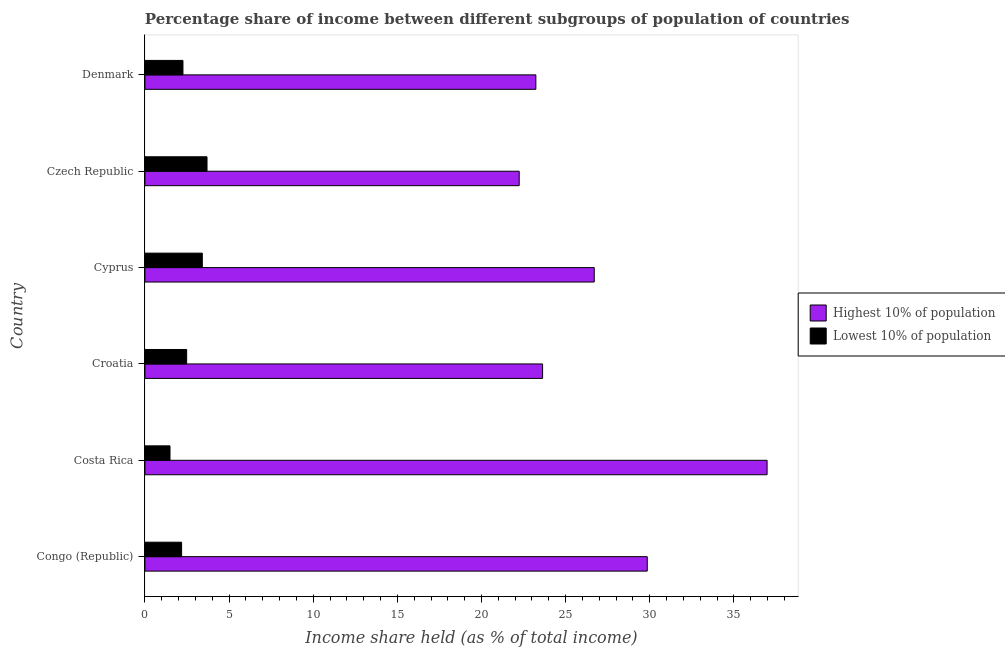How many different coloured bars are there?
Keep it short and to the point. 2. How many groups of bars are there?
Your answer should be very brief. 6. Are the number of bars on each tick of the Y-axis equal?
Provide a short and direct response. Yes. How many bars are there on the 1st tick from the bottom?
Provide a succinct answer. 2. What is the label of the 2nd group of bars from the top?
Offer a terse response. Czech Republic. In how many cases, is the number of bars for a given country not equal to the number of legend labels?
Provide a succinct answer. 0. What is the income share held by lowest 10% of the population in Denmark?
Your answer should be very brief. 2.26. Across all countries, what is the maximum income share held by lowest 10% of the population?
Offer a terse response. 3.69. Across all countries, what is the minimum income share held by lowest 10% of the population?
Keep it short and to the point. 1.49. In which country was the income share held by lowest 10% of the population maximum?
Give a very brief answer. Czech Republic. In which country was the income share held by lowest 10% of the population minimum?
Your response must be concise. Costa Rica. What is the total income share held by highest 10% of the population in the graph?
Provide a short and direct response. 162.62. What is the difference between the income share held by highest 10% of the population in Croatia and that in Denmark?
Make the answer very short. 0.4. What is the difference between the income share held by lowest 10% of the population in Costa Rica and the income share held by highest 10% of the population in Denmark?
Ensure brevity in your answer.  -21.74. What is the average income share held by highest 10% of the population per country?
Keep it short and to the point. 27.1. What is the difference between the income share held by highest 10% of the population and income share held by lowest 10% of the population in Czech Republic?
Offer a terse response. 18.55. What is the ratio of the income share held by highest 10% of the population in Czech Republic to that in Denmark?
Provide a succinct answer. 0.96. Is the income share held by highest 10% of the population in Congo (Republic) less than that in Croatia?
Make the answer very short. No. Is the difference between the income share held by highest 10% of the population in Congo (Republic) and Czech Republic greater than the difference between the income share held by lowest 10% of the population in Congo (Republic) and Czech Republic?
Make the answer very short. Yes. What is the difference between the highest and the second highest income share held by lowest 10% of the population?
Keep it short and to the point. 0.28. What is the difference between the highest and the lowest income share held by lowest 10% of the population?
Keep it short and to the point. 2.2. In how many countries, is the income share held by lowest 10% of the population greater than the average income share held by lowest 10% of the population taken over all countries?
Keep it short and to the point. 2. Is the sum of the income share held by lowest 10% of the population in Costa Rica and Croatia greater than the maximum income share held by highest 10% of the population across all countries?
Offer a terse response. No. What does the 2nd bar from the top in Czech Republic represents?
Keep it short and to the point. Highest 10% of population. What does the 2nd bar from the bottom in Czech Republic represents?
Your response must be concise. Lowest 10% of population. How many countries are there in the graph?
Make the answer very short. 6. What is the difference between two consecutive major ticks on the X-axis?
Your response must be concise. 5. Does the graph contain any zero values?
Ensure brevity in your answer.  No. Does the graph contain grids?
Give a very brief answer. No. Where does the legend appear in the graph?
Keep it short and to the point. Center right. What is the title of the graph?
Give a very brief answer. Percentage share of income between different subgroups of population of countries. What is the label or title of the X-axis?
Offer a terse response. Income share held (as % of total income). What is the Income share held (as % of total income) of Highest 10% of population in Congo (Republic)?
Keep it short and to the point. 29.85. What is the Income share held (as % of total income) of Lowest 10% of population in Congo (Republic)?
Provide a short and direct response. 2.18. What is the Income share held (as % of total income) in Highest 10% of population in Costa Rica?
Ensure brevity in your answer.  36.97. What is the Income share held (as % of total income) of Lowest 10% of population in Costa Rica?
Give a very brief answer. 1.49. What is the Income share held (as % of total income) in Highest 10% of population in Croatia?
Provide a succinct answer. 23.63. What is the Income share held (as % of total income) of Lowest 10% of population in Croatia?
Offer a terse response. 2.48. What is the Income share held (as % of total income) in Highest 10% of population in Cyprus?
Your answer should be compact. 26.7. What is the Income share held (as % of total income) in Lowest 10% of population in Cyprus?
Your response must be concise. 3.41. What is the Income share held (as % of total income) in Highest 10% of population in Czech Republic?
Make the answer very short. 22.24. What is the Income share held (as % of total income) of Lowest 10% of population in Czech Republic?
Your answer should be compact. 3.69. What is the Income share held (as % of total income) in Highest 10% of population in Denmark?
Offer a very short reply. 23.23. What is the Income share held (as % of total income) of Lowest 10% of population in Denmark?
Give a very brief answer. 2.26. Across all countries, what is the maximum Income share held (as % of total income) in Highest 10% of population?
Provide a short and direct response. 36.97. Across all countries, what is the maximum Income share held (as % of total income) in Lowest 10% of population?
Your answer should be very brief. 3.69. Across all countries, what is the minimum Income share held (as % of total income) of Highest 10% of population?
Offer a terse response. 22.24. Across all countries, what is the minimum Income share held (as % of total income) in Lowest 10% of population?
Provide a short and direct response. 1.49. What is the total Income share held (as % of total income) in Highest 10% of population in the graph?
Offer a terse response. 162.62. What is the total Income share held (as % of total income) in Lowest 10% of population in the graph?
Your answer should be very brief. 15.51. What is the difference between the Income share held (as % of total income) in Highest 10% of population in Congo (Republic) and that in Costa Rica?
Your answer should be very brief. -7.12. What is the difference between the Income share held (as % of total income) of Lowest 10% of population in Congo (Republic) and that in Costa Rica?
Make the answer very short. 0.69. What is the difference between the Income share held (as % of total income) of Highest 10% of population in Congo (Republic) and that in Croatia?
Provide a succinct answer. 6.22. What is the difference between the Income share held (as % of total income) of Highest 10% of population in Congo (Republic) and that in Cyprus?
Give a very brief answer. 3.15. What is the difference between the Income share held (as % of total income) in Lowest 10% of population in Congo (Republic) and that in Cyprus?
Ensure brevity in your answer.  -1.23. What is the difference between the Income share held (as % of total income) of Highest 10% of population in Congo (Republic) and that in Czech Republic?
Keep it short and to the point. 7.61. What is the difference between the Income share held (as % of total income) in Lowest 10% of population in Congo (Republic) and that in Czech Republic?
Give a very brief answer. -1.51. What is the difference between the Income share held (as % of total income) in Highest 10% of population in Congo (Republic) and that in Denmark?
Give a very brief answer. 6.62. What is the difference between the Income share held (as % of total income) in Lowest 10% of population in Congo (Republic) and that in Denmark?
Your answer should be compact. -0.08. What is the difference between the Income share held (as % of total income) of Highest 10% of population in Costa Rica and that in Croatia?
Offer a very short reply. 13.34. What is the difference between the Income share held (as % of total income) of Lowest 10% of population in Costa Rica and that in Croatia?
Keep it short and to the point. -0.99. What is the difference between the Income share held (as % of total income) of Highest 10% of population in Costa Rica and that in Cyprus?
Your answer should be very brief. 10.27. What is the difference between the Income share held (as % of total income) of Lowest 10% of population in Costa Rica and that in Cyprus?
Offer a very short reply. -1.92. What is the difference between the Income share held (as % of total income) of Highest 10% of population in Costa Rica and that in Czech Republic?
Your answer should be very brief. 14.73. What is the difference between the Income share held (as % of total income) of Lowest 10% of population in Costa Rica and that in Czech Republic?
Give a very brief answer. -2.2. What is the difference between the Income share held (as % of total income) in Highest 10% of population in Costa Rica and that in Denmark?
Make the answer very short. 13.74. What is the difference between the Income share held (as % of total income) of Lowest 10% of population in Costa Rica and that in Denmark?
Offer a terse response. -0.77. What is the difference between the Income share held (as % of total income) of Highest 10% of population in Croatia and that in Cyprus?
Ensure brevity in your answer.  -3.07. What is the difference between the Income share held (as % of total income) of Lowest 10% of population in Croatia and that in Cyprus?
Give a very brief answer. -0.93. What is the difference between the Income share held (as % of total income) of Highest 10% of population in Croatia and that in Czech Republic?
Make the answer very short. 1.39. What is the difference between the Income share held (as % of total income) of Lowest 10% of population in Croatia and that in Czech Republic?
Give a very brief answer. -1.21. What is the difference between the Income share held (as % of total income) in Highest 10% of population in Croatia and that in Denmark?
Keep it short and to the point. 0.4. What is the difference between the Income share held (as % of total income) of Lowest 10% of population in Croatia and that in Denmark?
Offer a very short reply. 0.22. What is the difference between the Income share held (as % of total income) of Highest 10% of population in Cyprus and that in Czech Republic?
Keep it short and to the point. 4.46. What is the difference between the Income share held (as % of total income) of Lowest 10% of population in Cyprus and that in Czech Republic?
Your response must be concise. -0.28. What is the difference between the Income share held (as % of total income) of Highest 10% of population in Cyprus and that in Denmark?
Keep it short and to the point. 3.47. What is the difference between the Income share held (as % of total income) of Lowest 10% of population in Cyprus and that in Denmark?
Ensure brevity in your answer.  1.15. What is the difference between the Income share held (as % of total income) of Highest 10% of population in Czech Republic and that in Denmark?
Your answer should be very brief. -0.99. What is the difference between the Income share held (as % of total income) of Lowest 10% of population in Czech Republic and that in Denmark?
Keep it short and to the point. 1.43. What is the difference between the Income share held (as % of total income) in Highest 10% of population in Congo (Republic) and the Income share held (as % of total income) in Lowest 10% of population in Costa Rica?
Your response must be concise. 28.36. What is the difference between the Income share held (as % of total income) of Highest 10% of population in Congo (Republic) and the Income share held (as % of total income) of Lowest 10% of population in Croatia?
Provide a succinct answer. 27.37. What is the difference between the Income share held (as % of total income) of Highest 10% of population in Congo (Republic) and the Income share held (as % of total income) of Lowest 10% of population in Cyprus?
Make the answer very short. 26.44. What is the difference between the Income share held (as % of total income) of Highest 10% of population in Congo (Republic) and the Income share held (as % of total income) of Lowest 10% of population in Czech Republic?
Give a very brief answer. 26.16. What is the difference between the Income share held (as % of total income) in Highest 10% of population in Congo (Republic) and the Income share held (as % of total income) in Lowest 10% of population in Denmark?
Offer a terse response. 27.59. What is the difference between the Income share held (as % of total income) of Highest 10% of population in Costa Rica and the Income share held (as % of total income) of Lowest 10% of population in Croatia?
Your answer should be compact. 34.49. What is the difference between the Income share held (as % of total income) of Highest 10% of population in Costa Rica and the Income share held (as % of total income) of Lowest 10% of population in Cyprus?
Your response must be concise. 33.56. What is the difference between the Income share held (as % of total income) in Highest 10% of population in Costa Rica and the Income share held (as % of total income) in Lowest 10% of population in Czech Republic?
Your response must be concise. 33.28. What is the difference between the Income share held (as % of total income) of Highest 10% of population in Costa Rica and the Income share held (as % of total income) of Lowest 10% of population in Denmark?
Your response must be concise. 34.71. What is the difference between the Income share held (as % of total income) of Highest 10% of population in Croatia and the Income share held (as % of total income) of Lowest 10% of population in Cyprus?
Your response must be concise. 20.22. What is the difference between the Income share held (as % of total income) in Highest 10% of population in Croatia and the Income share held (as % of total income) in Lowest 10% of population in Czech Republic?
Offer a very short reply. 19.94. What is the difference between the Income share held (as % of total income) of Highest 10% of population in Croatia and the Income share held (as % of total income) of Lowest 10% of population in Denmark?
Your answer should be very brief. 21.37. What is the difference between the Income share held (as % of total income) of Highest 10% of population in Cyprus and the Income share held (as % of total income) of Lowest 10% of population in Czech Republic?
Make the answer very short. 23.01. What is the difference between the Income share held (as % of total income) of Highest 10% of population in Cyprus and the Income share held (as % of total income) of Lowest 10% of population in Denmark?
Provide a short and direct response. 24.44. What is the difference between the Income share held (as % of total income) of Highest 10% of population in Czech Republic and the Income share held (as % of total income) of Lowest 10% of population in Denmark?
Offer a terse response. 19.98. What is the average Income share held (as % of total income) in Highest 10% of population per country?
Ensure brevity in your answer.  27.1. What is the average Income share held (as % of total income) of Lowest 10% of population per country?
Provide a short and direct response. 2.58. What is the difference between the Income share held (as % of total income) of Highest 10% of population and Income share held (as % of total income) of Lowest 10% of population in Congo (Republic)?
Your answer should be very brief. 27.67. What is the difference between the Income share held (as % of total income) in Highest 10% of population and Income share held (as % of total income) in Lowest 10% of population in Costa Rica?
Make the answer very short. 35.48. What is the difference between the Income share held (as % of total income) of Highest 10% of population and Income share held (as % of total income) of Lowest 10% of population in Croatia?
Your answer should be very brief. 21.15. What is the difference between the Income share held (as % of total income) of Highest 10% of population and Income share held (as % of total income) of Lowest 10% of population in Cyprus?
Keep it short and to the point. 23.29. What is the difference between the Income share held (as % of total income) in Highest 10% of population and Income share held (as % of total income) in Lowest 10% of population in Czech Republic?
Your response must be concise. 18.55. What is the difference between the Income share held (as % of total income) of Highest 10% of population and Income share held (as % of total income) of Lowest 10% of population in Denmark?
Offer a very short reply. 20.97. What is the ratio of the Income share held (as % of total income) of Highest 10% of population in Congo (Republic) to that in Costa Rica?
Offer a terse response. 0.81. What is the ratio of the Income share held (as % of total income) of Lowest 10% of population in Congo (Republic) to that in Costa Rica?
Ensure brevity in your answer.  1.46. What is the ratio of the Income share held (as % of total income) of Highest 10% of population in Congo (Republic) to that in Croatia?
Your answer should be compact. 1.26. What is the ratio of the Income share held (as % of total income) in Lowest 10% of population in Congo (Republic) to that in Croatia?
Give a very brief answer. 0.88. What is the ratio of the Income share held (as % of total income) of Highest 10% of population in Congo (Republic) to that in Cyprus?
Provide a short and direct response. 1.12. What is the ratio of the Income share held (as % of total income) in Lowest 10% of population in Congo (Republic) to that in Cyprus?
Provide a succinct answer. 0.64. What is the ratio of the Income share held (as % of total income) of Highest 10% of population in Congo (Republic) to that in Czech Republic?
Your response must be concise. 1.34. What is the ratio of the Income share held (as % of total income) in Lowest 10% of population in Congo (Republic) to that in Czech Republic?
Your response must be concise. 0.59. What is the ratio of the Income share held (as % of total income) in Highest 10% of population in Congo (Republic) to that in Denmark?
Your answer should be very brief. 1.28. What is the ratio of the Income share held (as % of total income) in Lowest 10% of population in Congo (Republic) to that in Denmark?
Ensure brevity in your answer.  0.96. What is the ratio of the Income share held (as % of total income) of Highest 10% of population in Costa Rica to that in Croatia?
Your response must be concise. 1.56. What is the ratio of the Income share held (as % of total income) in Lowest 10% of population in Costa Rica to that in Croatia?
Provide a succinct answer. 0.6. What is the ratio of the Income share held (as % of total income) in Highest 10% of population in Costa Rica to that in Cyprus?
Make the answer very short. 1.38. What is the ratio of the Income share held (as % of total income) in Lowest 10% of population in Costa Rica to that in Cyprus?
Provide a succinct answer. 0.44. What is the ratio of the Income share held (as % of total income) in Highest 10% of population in Costa Rica to that in Czech Republic?
Make the answer very short. 1.66. What is the ratio of the Income share held (as % of total income) of Lowest 10% of population in Costa Rica to that in Czech Republic?
Your response must be concise. 0.4. What is the ratio of the Income share held (as % of total income) of Highest 10% of population in Costa Rica to that in Denmark?
Your response must be concise. 1.59. What is the ratio of the Income share held (as % of total income) in Lowest 10% of population in Costa Rica to that in Denmark?
Ensure brevity in your answer.  0.66. What is the ratio of the Income share held (as % of total income) in Highest 10% of population in Croatia to that in Cyprus?
Provide a short and direct response. 0.89. What is the ratio of the Income share held (as % of total income) of Lowest 10% of population in Croatia to that in Cyprus?
Give a very brief answer. 0.73. What is the ratio of the Income share held (as % of total income) in Highest 10% of population in Croatia to that in Czech Republic?
Offer a terse response. 1.06. What is the ratio of the Income share held (as % of total income) of Lowest 10% of population in Croatia to that in Czech Republic?
Your answer should be very brief. 0.67. What is the ratio of the Income share held (as % of total income) of Highest 10% of population in Croatia to that in Denmark?
Provide a short and direct response. 1.02. What is the ratio of the Income share held (as % of total income) in Lowest 10% of population in Croatia to that in Denmark?
Your answer should be compact. 1.1. What is the ratio of the Income share held (as % of total income) of Highest 10% of population in Cyprus to that in Czech Republic?
Keep it short and to the point. 1.2. What is the ratio of the Income share held (as % of total income) in Lowest 10% of population in Cyprus to that in Czech Republic?
Provide a short and direct response. 0.92. What is the ratio of the Income share held (as % of total income) of Highest 10% of population in Cyprus to that in Denmark?
Your response must be concise. 1.15. What is the ratio of the Income share held (as % of total income) in Lowest 10% of population in Cyprus to that in Denmark?
Provide a succinct answer. 1.51. What is the ratio of the Income share held (as % of total income) in Highest 10% of population in Czech Republic to that in Denmark?
Your answer should be very brief. 0.96. What is the ratio of the Income share held (as % of total income) of Lowest 10% of population in Czech Republic to that in Denmark?
Your answer should be compact. 1.63. What is the difference between the highest and the second highest Income share held (as % of total income) of Highest 10% of population?
Your response must be concise. 7.12. What is the difference between the highest and the second highest Income share held (as % of total income) in Lowest 10% of population?
Ensure brevity in your answer.  0.28. What is the difference between the highest and the lowest Income share held (as % of total income) in Highest 10% of population?
Give a very brief answer. 14.73. 